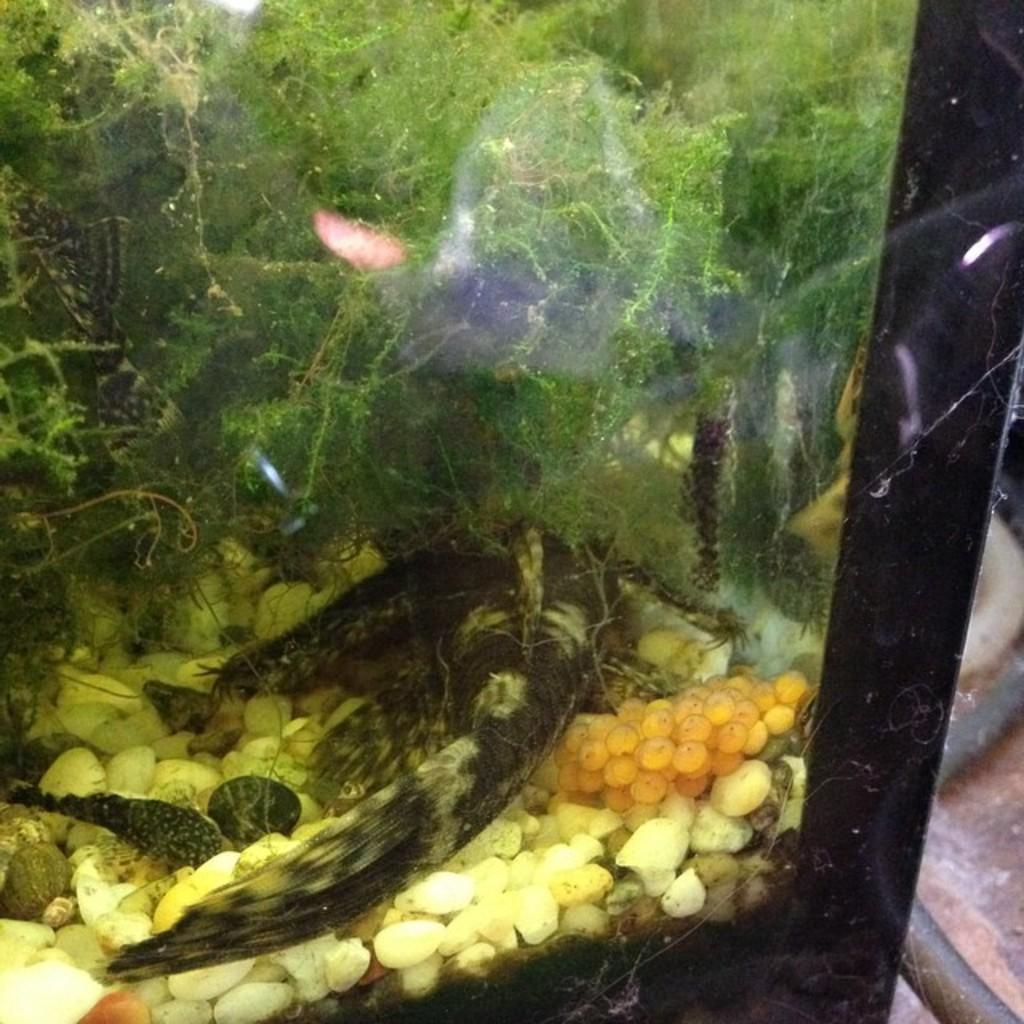What is the main object in the image? There is an aquarium in the image. What can be found inside the aquarium? Inside the aquarium, there are fish, water, stones, and green plants. What type of insurance is being sold at the seashore in the image? There is no seashore or insurance being sold in the image; it features an aquarium with fish, water, stones, and green plants. 